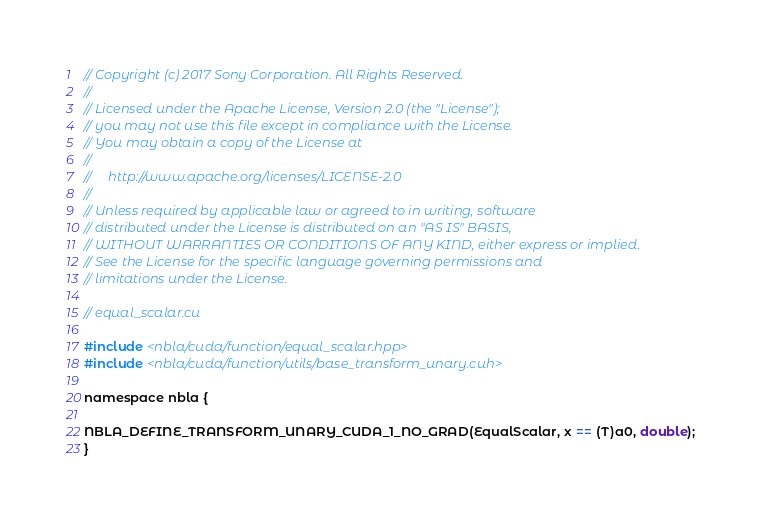Convert code to text. <code><loc_0><loc_0><loc_500><loc_500><_Cuda_>// Copyright (c) 2017 Sony Corporation. All Rights Reserved.
//
// Licensed under the Apache License, Version 2.0 (the "License");
// you may not use this file except in compliance with the License.
// You may obtain a copy of the License at
//
//     http://www.apache.org/licenses/LICENSE-2.0
//
// Unless required by applicable law or agreed to in writing, software
// distributed under the License is distributed on an "AS IS" BASIS,
// WITHOUT WARRANTIES OR CONDITIONS OF ANY KIND, either express or implied.
// See the License for the specific language governing permissions and
// limitations under the License.

// equal_scalar.cu

#include <nbla/cuda/function/equal_scalar.hpp>
#include <nbla/cuda/function/utils/base_transform_unary.cuh>

namespace nbla {

NBLA_DEFINE_TRANSFORM_UNARY_CUDA_1_NO_GRAD(EqualScalar, x == (T)a0, double);
}
</code> 